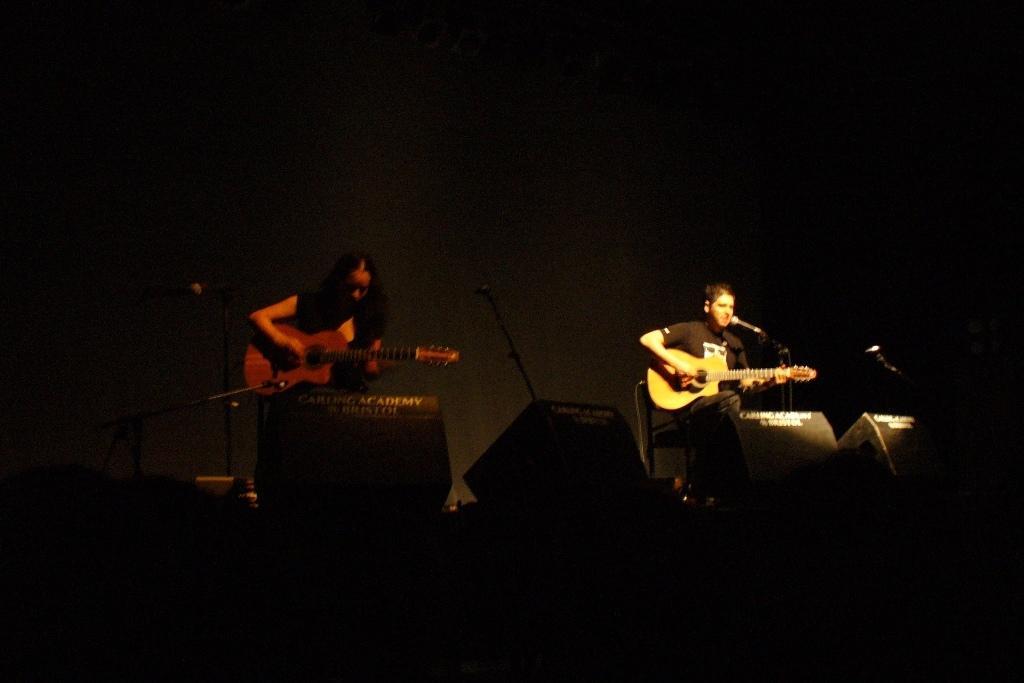How would you summarize this image in a sentence or two? In this image I can see two people are playing the musical instruments. 